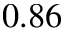Convert formula to latex. <formula><loc_0><loc_0><loc_500><loc_500>0 . 8 6</formula> 